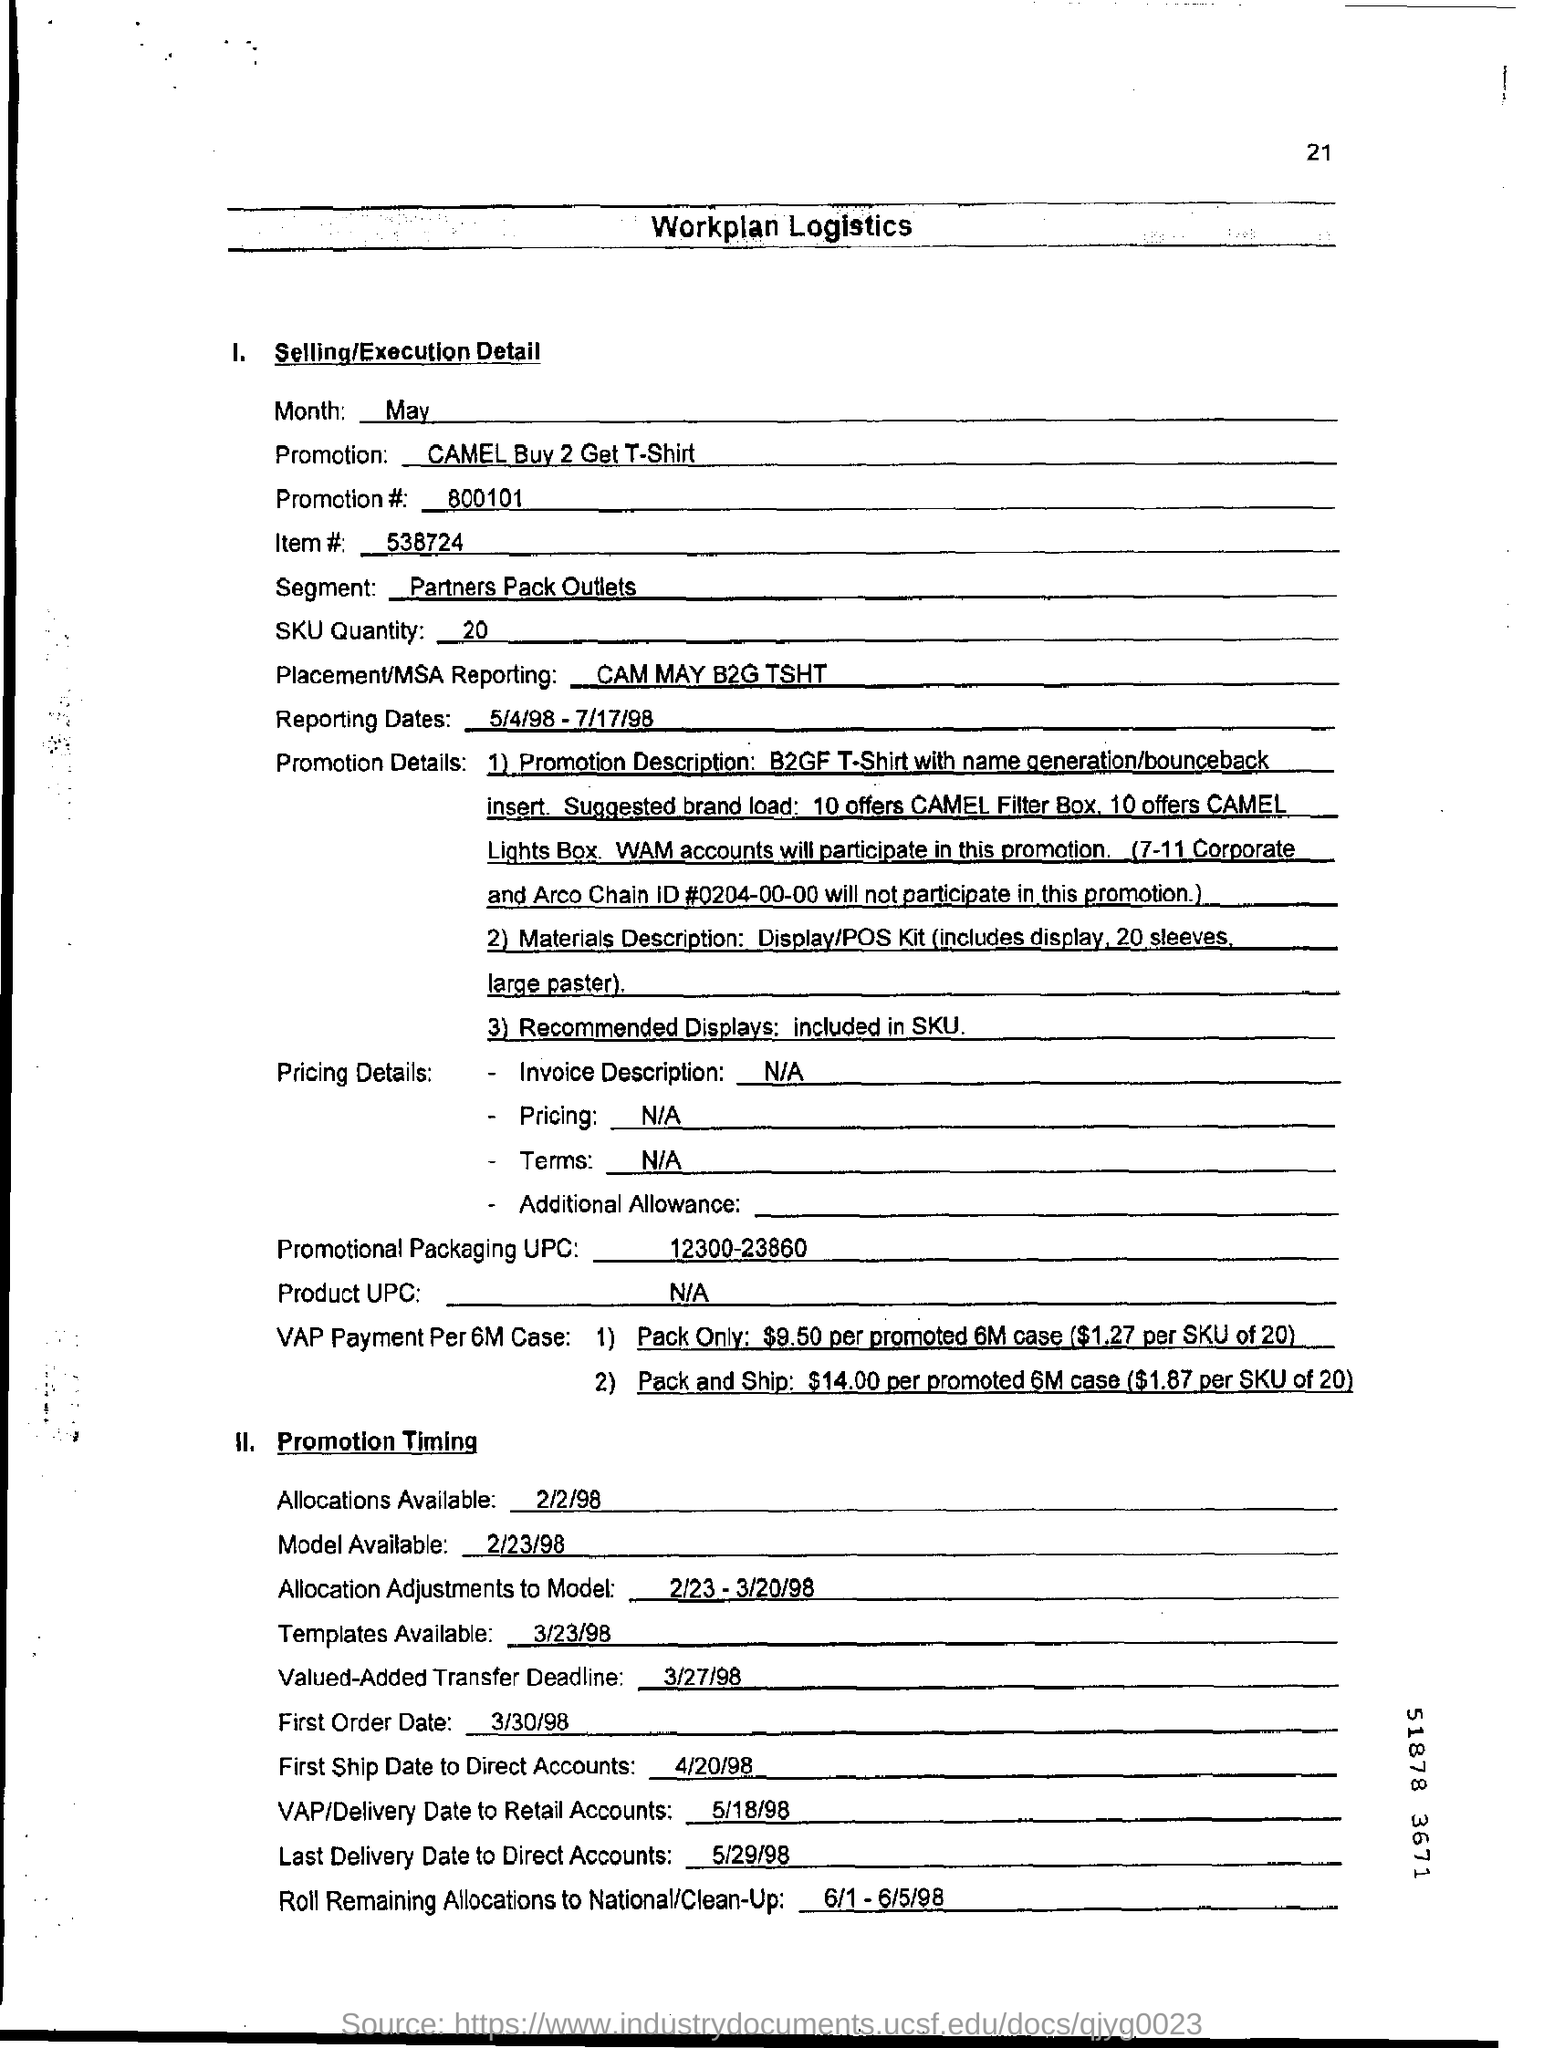What is the reporting date mentioned ?
Make the answer very short. 5/4/98 - 7/17/98. What is the segment ?
Provide a succinct answer. Partners Pack Outlets. What is the sku quantity ?
Offer a very short reply. 20. What is the item# number?
Your answer should be very brief. 538724. What is the placement/msa reporting ?
Your answer should be very brief. CAM MAY B2G TSHT. What is the first order date ?
Ensure brevity in your answer.  3/30/98. What is the last delivery date to direct accounts?
Your response must be concise. 5/29/98. What is the first ship date to direct accounts ?
Offer a terse response. 4/20/98. What is the promotion number?
Provide a short and direct response. 800101. What is the promotion number ?
Your answer should be very brief. 800101. 